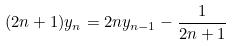Convert formula to latex. <formula><loc_0><loc_0><loc_500><loc_500>( 2 n + 1 ) y _ { n } = 2 n y _ { n - 1 } - \frac { 1 } { 2 n + 1 }</formula> 